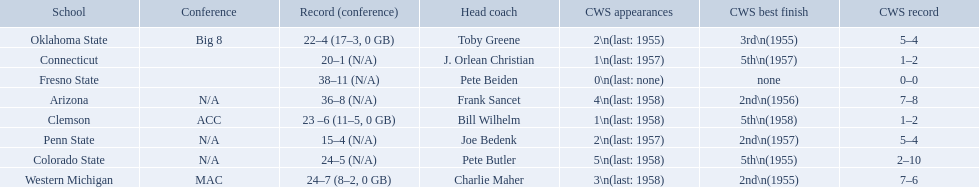What was the least amount of wins recorded by the losingest team? 15–4 (N/A). Which team held this record? Penn State. What are all of the schools? Arizona, Clemson, Colorado State, Connecticut, Fresno State, Oklahoma State, Penn State, Western Michigan. Which team had fewer than 20 wins? Penn State. 